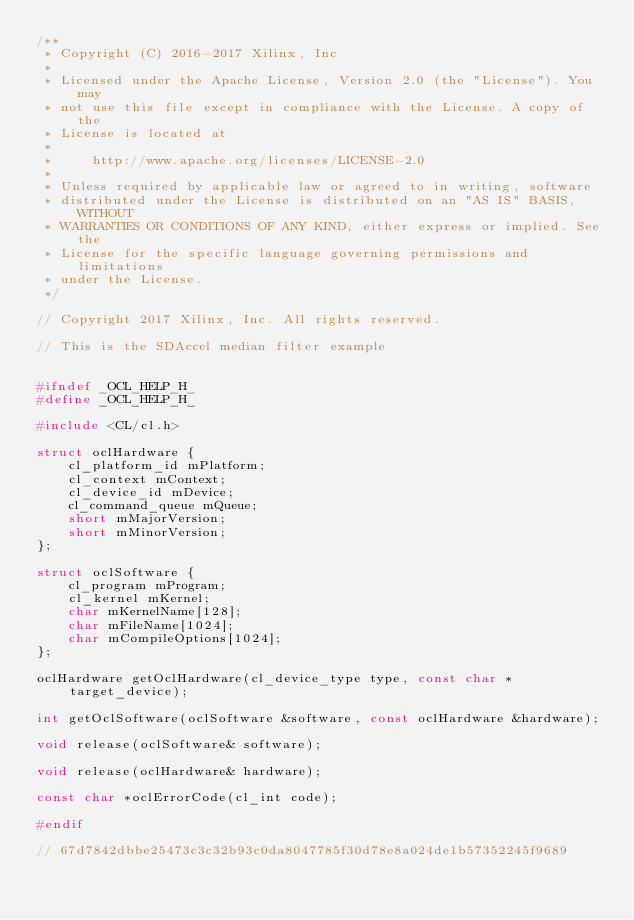<code> <loc_0><loc_0><loc_500><loc_500><_C_>/**
 * Copyright (C) 2016-2017 Xilinx, Inc
 *
 * Licensed under the Apache License, Version 2.0 (the "License"). You may
 * not use this file except in compliance with the License. A copy of the
 * License is located at
 *
 *     http://www.apache.org/licenses/LICENSE-2.0
 *
 * Unless required by applicable law or agreed to in writing, software
 * distributed under the License is distributed on an "AS IS" BASIS, WITHOUT
 * WARRANTIES OR CONDITIONS OF ANY KIND, either express or implied. See the
 * License for the specific language governing permissions and limitations
 * under the License.
 */

// Copyright 2017 Xilinx, Inc. All rights reserved.

// This is the SDAccel median filter example


#ifndef _OCL_HELP_H_
#define _OCL_HELP_H_

#include <CL/cl.h>

struct oclHardware {
    cl_platform_id mPlatform;
    cl_context mContext;
    cl_device_id mDevice;
    cl_command_queue mQueue;
    short mMajorVersion;
    short mMinorVersion;
};

struct oclSoftware {
    cl_program mProgram;
    cl_kernel mKernel;
    char mKernelName[128];
    char mFileName[1024];
    char mCompileOptions[1024];
};

oclHardware getOclHardware(cl_device_type type, const char *target_device);

int getOclSoftware(oclSoftware &software, const oclHardware &hardware);

void release(oclSoftware& software);

void release(oclHardware& hardware);

const char *oclErrorCode(cl_int code);

#endif

// 67d7842dbbe25473c3c32b93c0da8047785f30d78e8a024de1b57352245f9689
</code> 